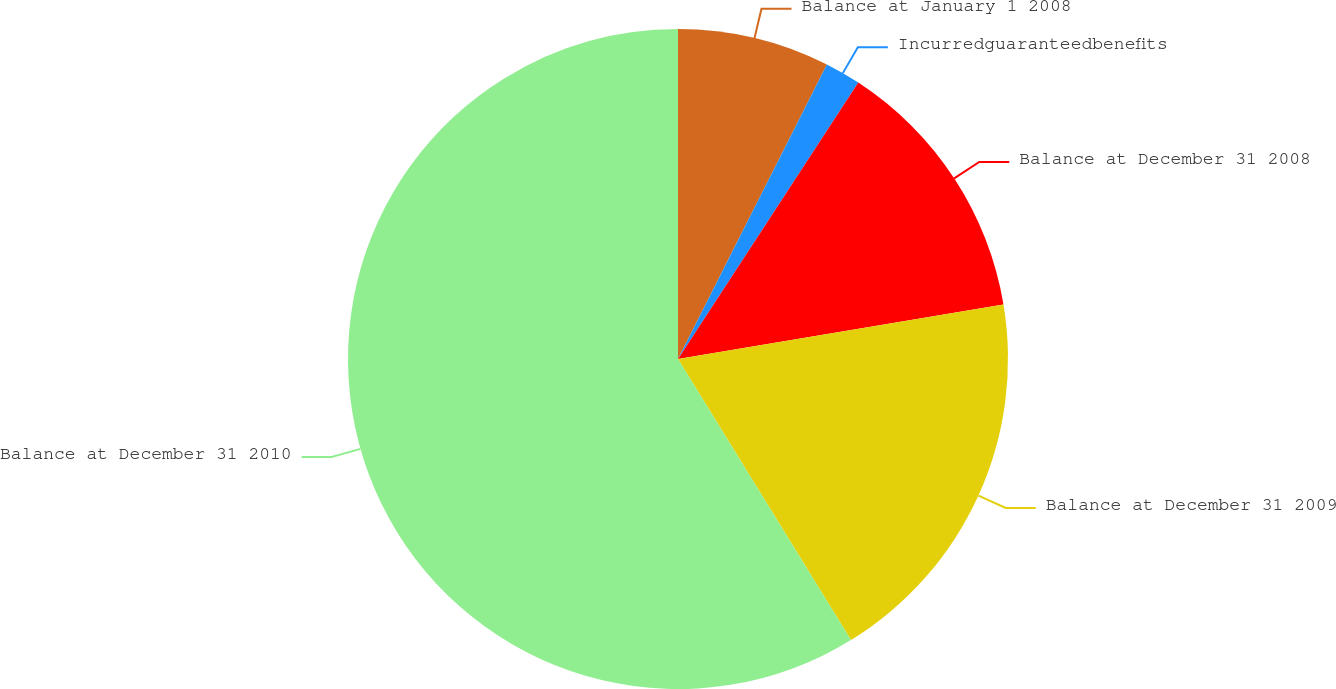Convert chart to OTSL. <chart><loc_0><loc_0><loc_500><loc_500><pie_chart><fcel>Balance at January 1 2008<fcel>Incurredguaranteedbenefits<fcel>Balance at December 31 2008<fcel>Balance at December 31 2009<fcel>Balance at December 31 2010<nl><fcel>7.45%<fcel>1.75%<fcel>13.16%<fcel>18.86%<fcel>58.78%<nl></chart> 